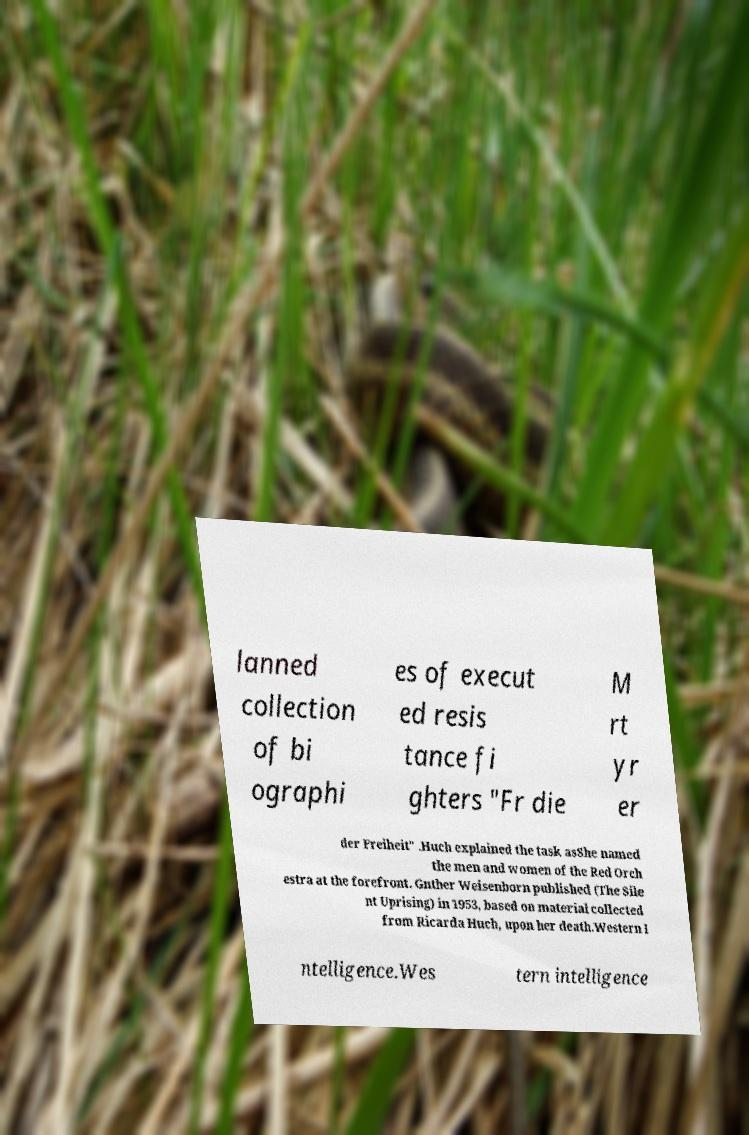Please read and relay the text visible in this image. What does it say? lanned collection of bi ographi es of execut ed resis tance fi ghters "Fr die M rt yr er der Freiheit" .Huch explained the task asShe named the men and women of the Red Orch estra at the forefront. Gnther Weisenborn published (The Sile nt Uprising) in 1953, based on material collected from Ricarda Huch, upon her death.Western I ntelligence.Wes tern intelligence 